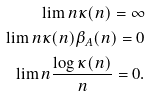<formula> <loc_0><loc_0><loc_500><loc_500>\lim n \kappa ( n ) = \infty \\ \lim n \kappa ( n ) \beta _ { A } ( n ) = 0 \\ \lim n \frac { \log \kappa ( n ) } n = 0 .</formula> 